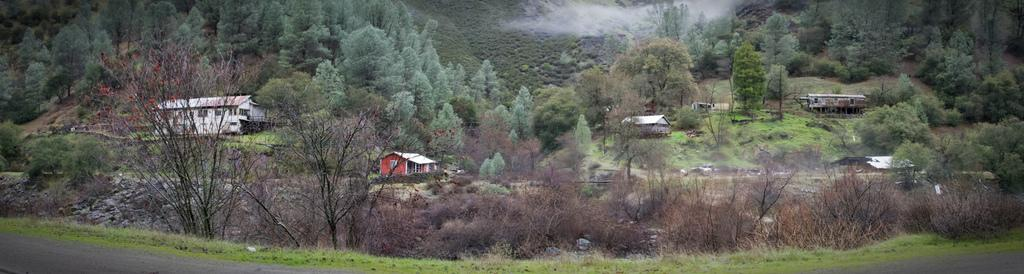What structures are located in the center of the image? There are sheds in the center of the image. What type of natural elements can be seen in the image? There are trees in the image. What type of man-made feature is at the bottom of the image? There is a road at the bottom of the image. How do the trees increase in size over time in the image? The image does not show the trees growing or changing in size over time; it is a static representation of the scene. Can you see any boats sailing on the road in the image? There are no boats or bodies of water present in the image, so sailing is not applicable. 